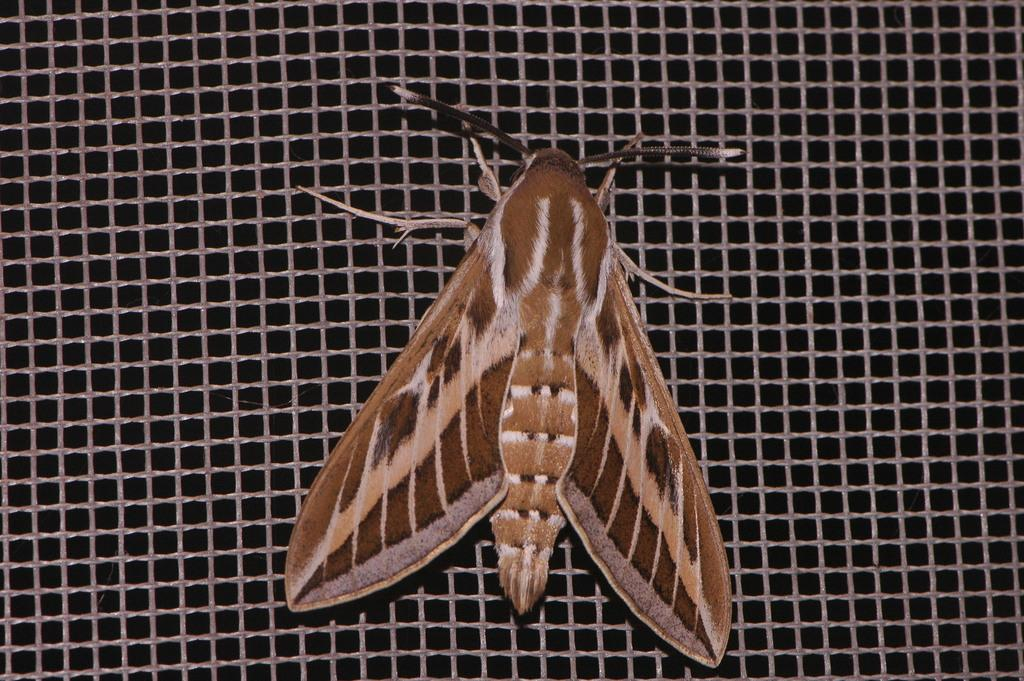What type of creature is present in the image? There is an insect in the image. What is the insect resting on? The insect is on a mesh. Where is the insect located in the image? The insect is located in the center of the image. What language does the insect speak in the image? Insects do not have the ability to speak any language, so this question cannot be answered. 